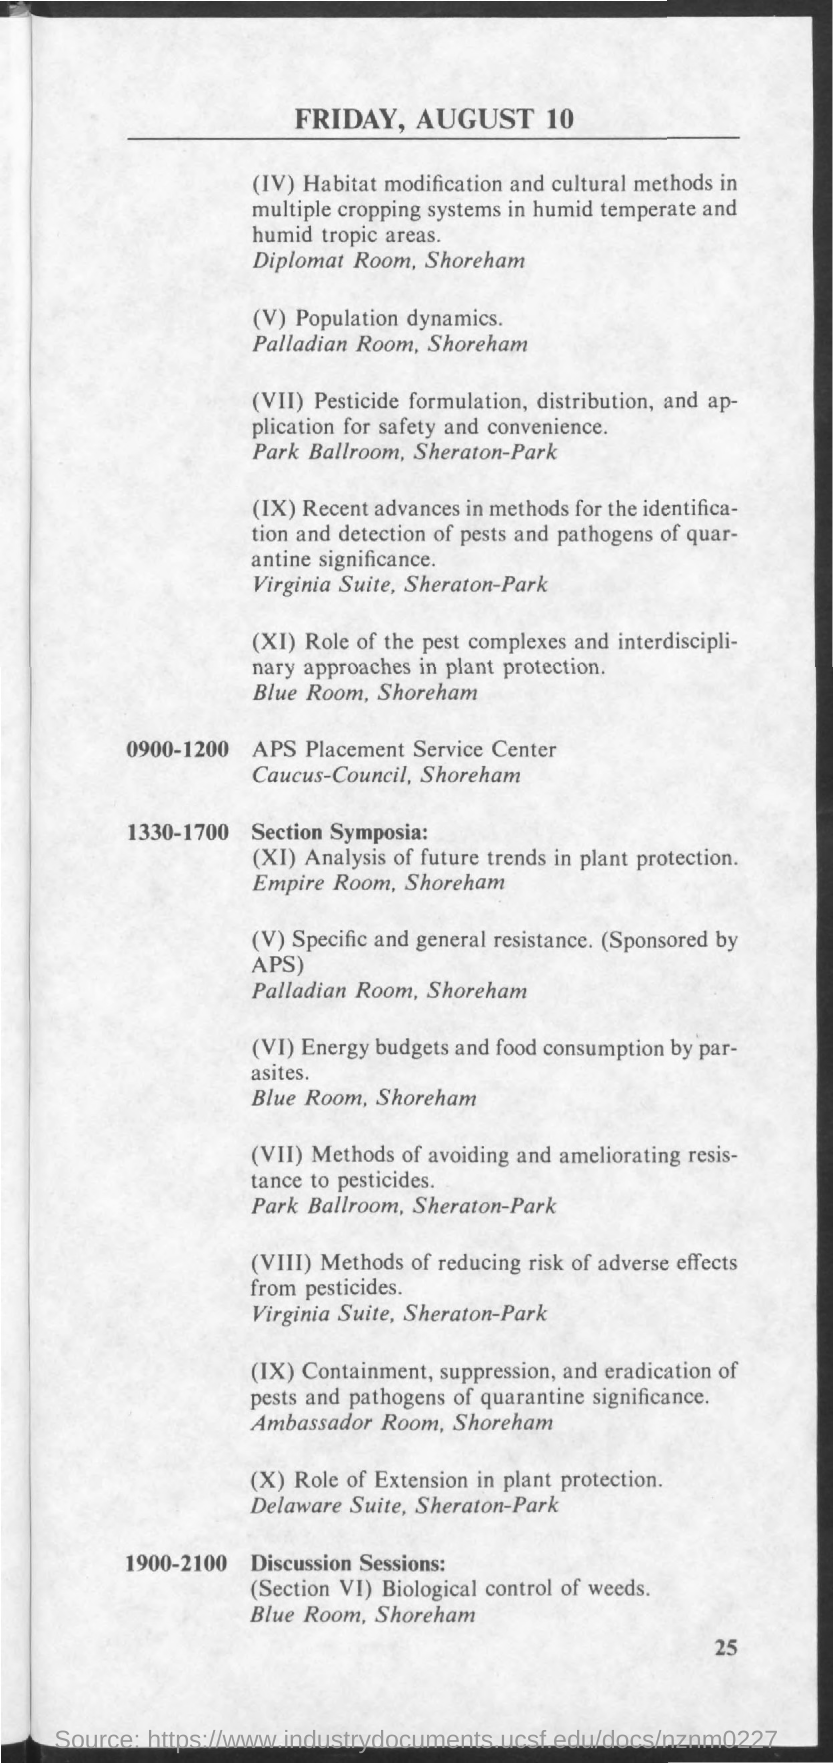What is the Page Number?
Make the answer very short. 25. Who sponsored "Specific and general resistance" section?
Ensure brevity in your answer.  Aps. 